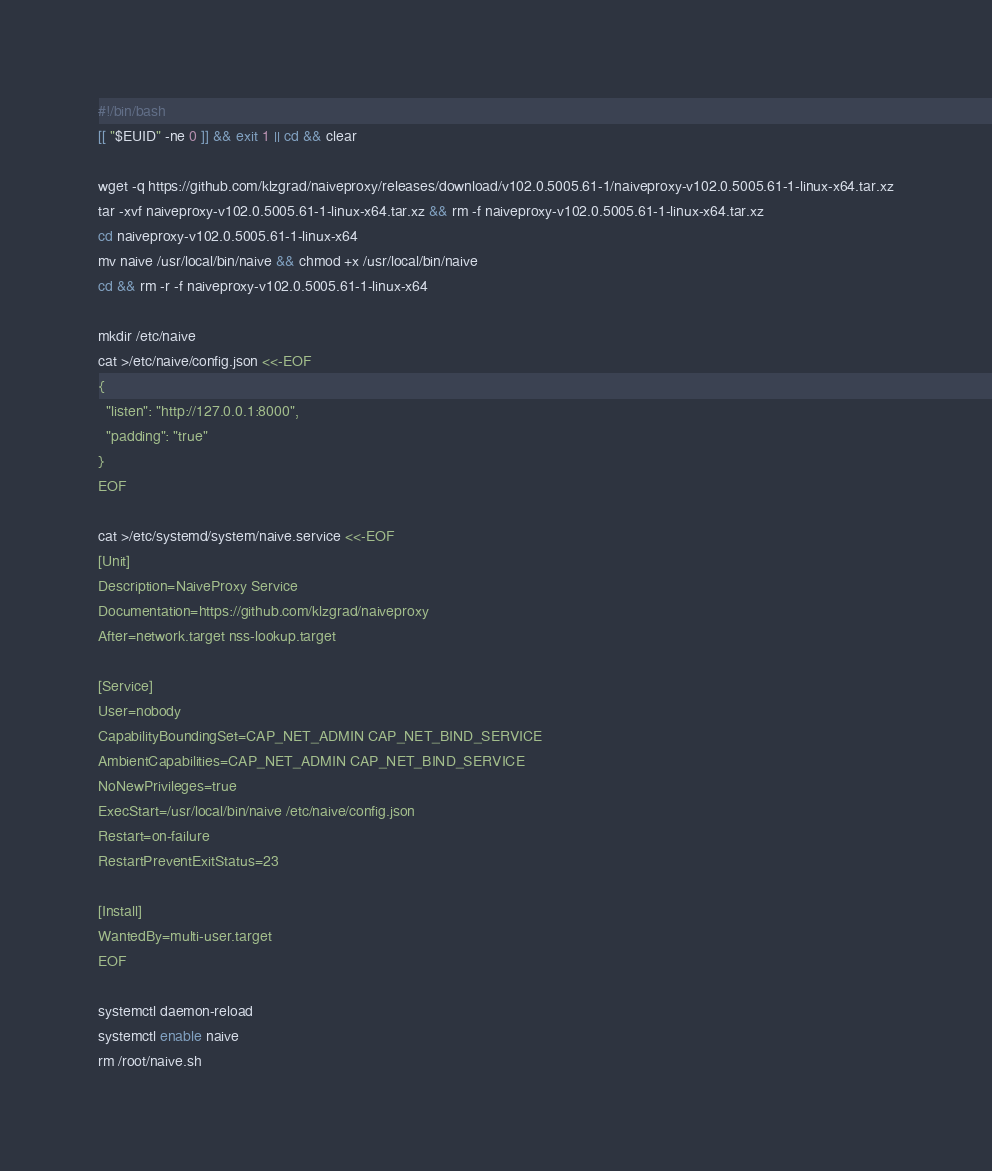Convert code to text. <code><loc_0><loc_0><loc_500><loc_500><_Bash_>#!/bin/bash
[[ "$EUID" -ne 0 ]] && exit 1 || cd && clear

wget -q https://github.com/klzgrad/naiveproxy/releases/download/v102.0.5005.61-1/naiveproxy-v102.0.5005.61-1-linux-x64.tar.xz
tar -xvf naiveproxy-v102.0.5005.61-1-linux-x64.tar.xz && rm -f naiveproxy-v102.0.5005.61-1-linux-x64.tar.xz
cd naiveproxy-v102.0.5005.61-1-linux-x64
mv naive /usr/local/bin/naive && chmod +x /usr/local/bin/naive
cd && rm -r -f naiveproxy-v102.0.5005.61-1-linux-x64

mkdir /etc/naive
cat >/etc/naive/config.json <<-EOF
{
  "listen": "http://127.0.0.1:8000",
  "padding": "true"
}
EOF

cat >/etc/systemd/system/naive.service <<-EOF
[Unit]
Description=NaiveProxy Service
Documentation=https://github.com/klzgrad/naiveproxy
After=network.target nss-lookup.target

[Service]
User=nobody
CapabilityBoundingSet=CAP_NET_ADMIN CAP_NET_BIND_SERVICE
AmbientCapabilities=CAP_NET_ADMIN CAP_NET_BIND_SERVICE
NoNewPrivileges=true
ExecStart=/usr/local/bin/naive /etc/naive/config.json
Restart=on-failure
RestartPreventExitStatus=23

[Install]
WantedBy=multi-user.target
EOF

systemctl daemon-reload
systemctl enable naive
rm /root/naive.sh
</code> 